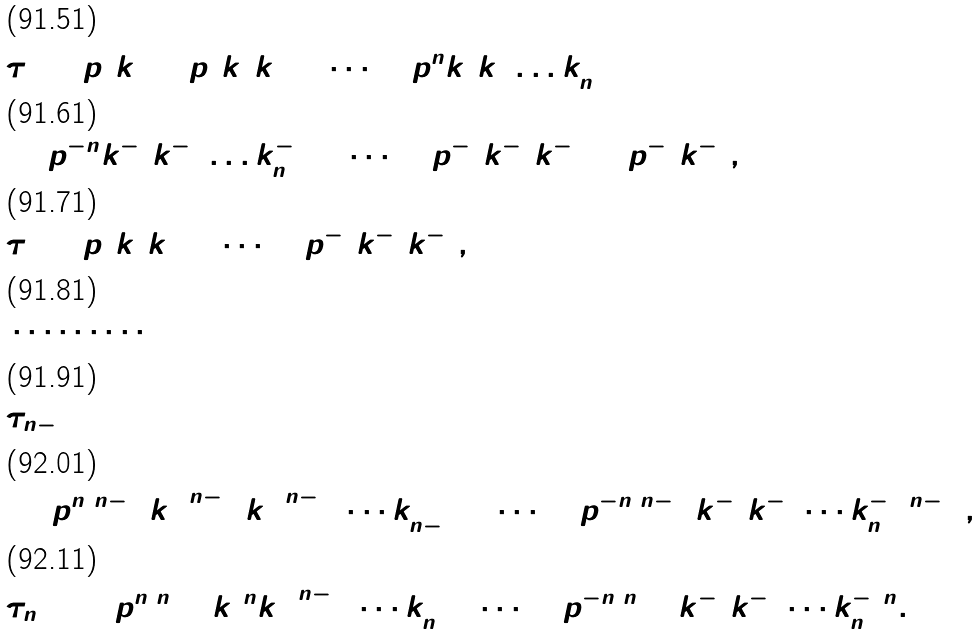Convert formula to latex. <formula><loc_0><loc_0><loc_500><loc_500>& \tau _ { 1 } = p ^ { 2 } k _ { 1 } ^ { 2 } + p ^ { 4 } k _ { 1 } ^ { 2 } k _ { 2 } ^ { 2 } + \cdots + p ^ { n } k _ { 1 } ^ { 2 } k _ { 2 } ^ { 2 } \dots k _ { n } ^ { 2 } \\ & + p ^ { - n } k _ { 1 } ^ { - 2 } k _ { 2 } ^ { - 2 } \dots k _ { n } ^ { - 2 } + \dots + p ^ { - 4 } k _ { 1 } ^ { - 2 } k _ { 2 } ^ { - 2 } + p ^ { - 2 } k _ { 1 } ^ { - 2 } , \\ & \tau _ { 2 } = p ^ { 6 } k _ { 1 } ^ { 4 } k _ { 2 } ^ { 2 } + \cdots + p ^ { - 6 } k _ { 1 } ^ { - 2 } k _ { 2 } ^ { - 4 } , \\ & \cdots \cdots \cdots \\ & \tau _ { n - 1 } \\ & = p ^ { n ( n - 1 ) } k _ { 1 } ^ { 2 ( n - 1 ) } k _ { 2 } ^ { 2 ( n - 2 ) } \cdots k _ { n - 1 } ^ { 2 } + \cdots + p ^ { - n ( n - 1 ) } k _ { 1 } ^ { - 2 } k _ { 2 } ^ { - 4 } \cdots k _ { n } ^ { - 2 ( n - 1 ) } , \\ & \tau _ { n + 1 } = p ^ { n ( n + 1 ) } k _ { 1 } ^ { 2 n } k _ { 2 } ^ { 2 ( n - 1 ) } \cdots k _ { n } ^ { 2 } + \cdots + p ^ { - n ( n + 1 ) } k _ { 1 } ^ { - 2 } k _ { 2 } ^ { - 4 } \cdots k _ { n } ^ { - 2 n } .</formula> 